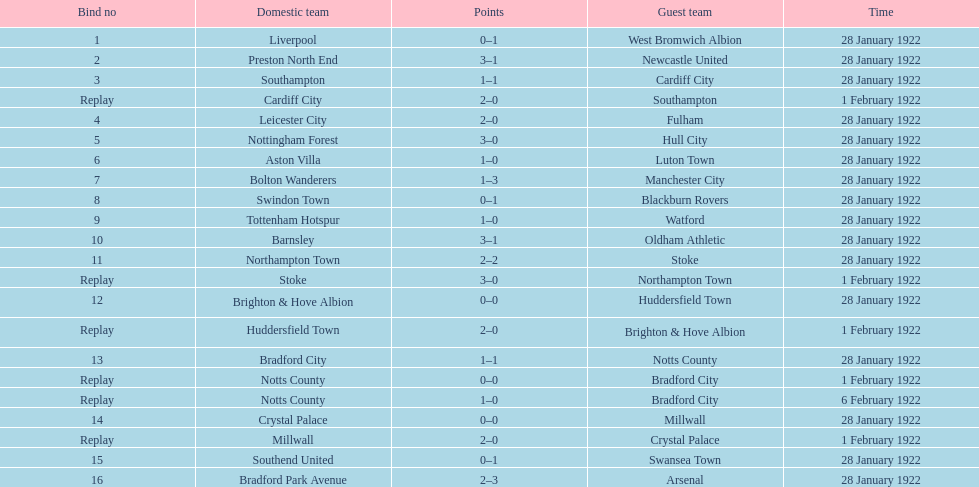Who is the first home team listed as having a score of 3-1? Preston North End. 